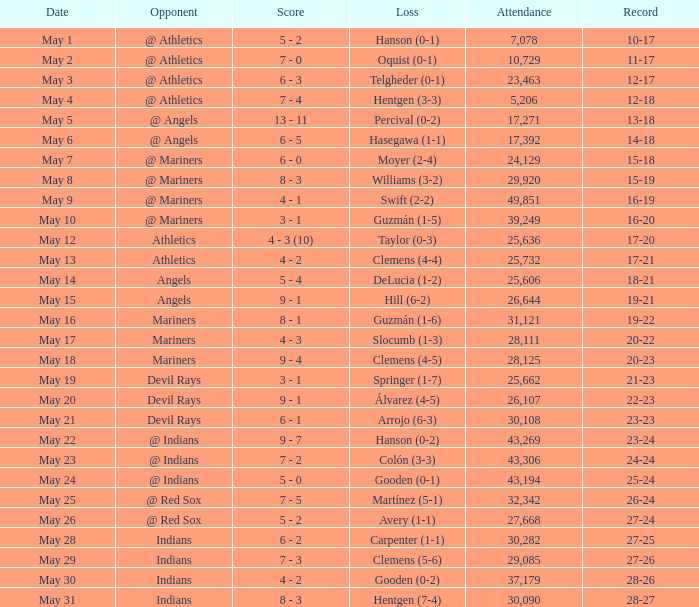For record 25-24, what is the sum of attendance? 1.0. 